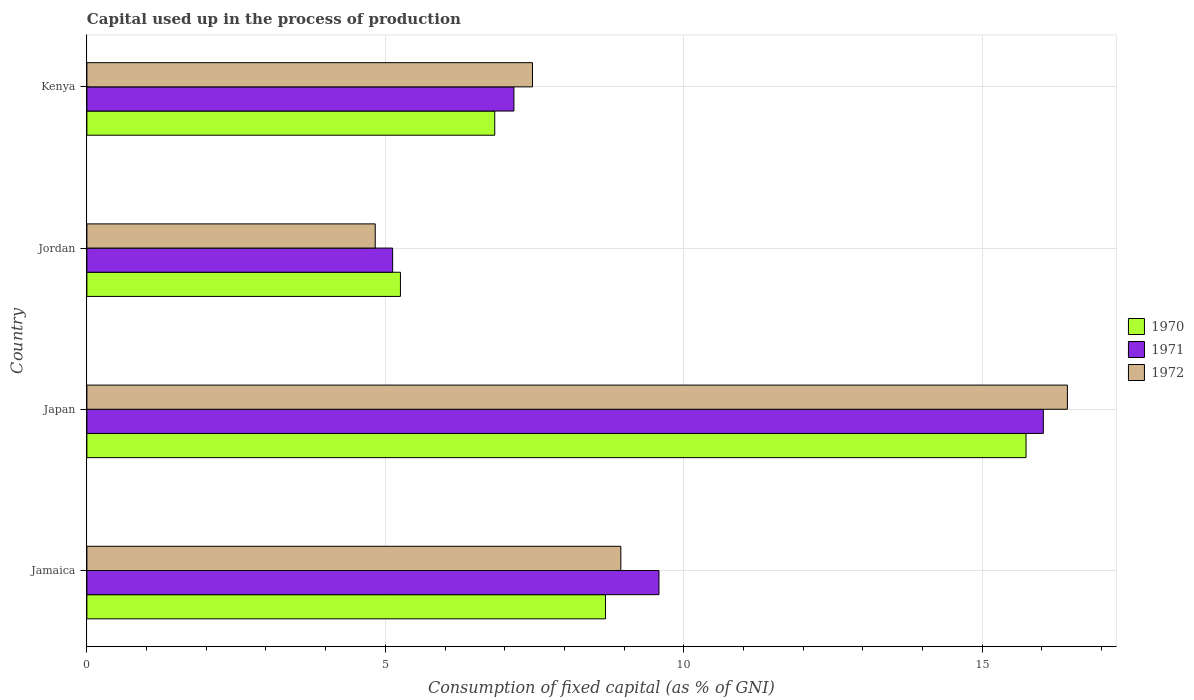Are the number of bars per tick equal to the number of legend labels?
Provide a short and direct response. Yes. Are the number of bars on each tick of the Y-axis equal?
Provide a succinct answer. Yes. How many bars are there on the 4th tick from the bottom?
Your response must be concise. 3. What is the label of the 1st group of bars from the top?
Your answer should be very brief. Kenya. What is the capital used up in the process of production in 1970 in Kenya?
Provide a succinct answer. 6.83. Across all countries, what is the maximum capital used up in the process of production in 1971?
Give a very brief answer. 16.02. Across all countries, what is the minimum capital used up in the process of production in 1971?
Your response must be concise. 5.12. In which country was the capital used up in the process of production in 1972 minimum?
Ensure brevity in your answer.  Jordan. What is the total capital used up in the process of production in 1970 in the graph?
Offer a very short reply. 36.51. What is the difference between the capital used up in the process of production in 1972 in Japan and that in Jordan?
Your answer should be compact. 11.6. What is the difference between the capital used up in the process of production in 1972 in Japan and the capital used up in the process of production in 1970 in Jordan?
Provide a short and direct response. 11.17. What is the average capital used up in the process of production in 1970 per country?
Offer a terse response. 9.13. What is the difference between the capital used up in the process of production in 1971 and capital used up in the process of production in 1970 in Japan?
Give a very brief answer. 0.29. What is the ratio of the capital used up in the process of production in 1972 in Japan to that in Jordan?
Offer a very short reply. 3.4. Is the capital used up in the process of production in 1972 in Japan less than that in Jordan?
Make the answer very short. No. What is the difference between the highest and the second highest capital used up in the process of production in 1972?
Give a very brief answer. 7.48. What is the difference between the highest and the lowest capital used up in the process of production in 1971?
Give a very brief answer. 10.9. Is the sum of the capital used up in the process of production in 1971 in Jamaica and Japan greater than the maximum capital used up in the process of production in 1972 across all countries?
Ensure brevity in your answer.  Yes. What does the 2nd bar from the bottom in Jamaica represents?
Provide a succinct answer. 1971. Is it the case that in every country, the sum of the capital used up in the process of production in 1972 and capital used up in the process of production in 1971 is greater than the capital used up in the process of production in 1970?
Give a very brief answer. Yes. Are all the bars in the graph horizontal?
Make the answer very short. Yes. What is the difference between two consecutive major ticks on the X-axis?
Offer a terse response. 5. Where does the legend appear in the graph?
Your answer should be compact. Center right. How many legend labels are there?
Provide a short and direct response. 3. How are the legend labels stacked?
Your response must be concise. Vertical. What is the title of the graph?
Your answer should be compact. Capital used up in the process of production. Does "2013" appear as one of the legend labels in the graph?
Provide a succinct answer. No. What is the label or title of the X-axis?
Your response must be concise. Consumption of fixed capital (as % of GNI). What is the label or title of the Y-axis?
Your answer should be very brief. Country. What is the Consumption of fixed capital (as % of GNI) in 1970 in Jamaica?
Give a very brief answer. 8.69. What is the Consumption of fixed capital (as % of GNI) in 1971 in Jamaica?
Provide a short and direct response. 9.58. What is the Consumption of fixed capital (as % of GNI) in 1972 in Jamaica?
Offer a very short reply. 8.95. What is the Consumption of fixed capital (as % of GNI) of 1970 in Japan?
Provide a succinct answer. 15.74. What is the Consumption of fixed capital (as % of GNI) of 1971 in Japan?
Your answer should be compact. 16.02. What is the Consumption of fixed capital (as % of GNI) of 1972 in Japan?
Offer a very short reply. 16.43. What is the Consumption of fixed capital (as % of GNI) of 1970 in Jordan?
Give a very brief answer. 5.25. What is the Consumption of fixed capital (as % of GNI) in 1971 in Jordan?
Your response must be concise. 5.12. What is the Consumption of fixed capital (as % of GNI) in 1972 in Jordan?
Your answer should be compact. 4.83. What is the Consumption of fixed capital (as % of GNI) in 1970 in Kenya?
Your answer should be compact. 6.83. What is the Consumption of fixed capital (as % of GNI) of 1971 in Kenya?
Keep it short and to the point. 7.15. What is the Consumption of fixed capital (as % of GNI) of 1972 in Kenya?
Ensure brevity in your answer.  7.47. Across all countries, what is the maximum Consumption of fixed capital (as % of GNI) in 1970?
Offer a terse response. 15.74. Across all countries, what is the maximum Consumption of fixed capital (as % of GNI) in 1971?
Provide a succinct answer. 16.02. Across all countries, what is the maximum Consumption of fixed capital (as % of GNI) of 1972?
Ensure brevity in your answer.  16.43. Across all countries, what is the minimum Consumption of fixed capital (as % of GNI) of 1970?
Your response must be concise. 5.25. Across all countries, what is the minimum Consumption of fixed capital (as % of GNI) of 1971?
Provide a succinct answer. 5.12. Across all countries, what is the minimum Consumption of fixed capital (as % of GNI) of 1972?
Provide a short and direct response. 4.83. What is the total Consumption of fixed capital (as % of GNI) of 1970 in the graph?
Provide a succinct answer. 36.51. What is the total Consumption of fixed capital (as % of GNI) of 1971 in the graph?
Provide a succinct answer. 37.89. What is the total Consumption of fixed capital (as % of GNI) in 1972 in the graph?
Your answer should be very brief. 37.67. What is the difference between the Consumption of fixed capital (as % of GNI) in 1970 in Jamaica and that in Japan?
Offer a very short reply. -7.05. What is the difference between the Consumption of fixed capital (as % of GNI) of 1971 in Jamaica and that in Japan?
Your answer should be very brief. -6.44. What is the difference between the Consumption of fixed capital (as % of GNI) of 1972 in Jamaica and that in Japan?
Your answer should be compact. -7.48. What is the difference between the Consumption of fixed capital (as % of GNI) in 1970 in Jamaica and that in Jordan?
Make the answer very short. 3.44. What is the difference between the Consumption of fixed capital (as % of GNI) in 1971 in Jamaica and that in Jordan?
Provide a succinct answer. 4.46. What is the difference between the Consumption of fixed capital (as % of GNI) of 1972 in Jamaica and that in Jordan?
Provide a short and direct response. 4.11. What is the difference between the Consumption of fixed capital (as % of GNI) of 1970 in Jamaica and that in Kenya?
Provide a succinct answer. 1.86. What is the difference between the Consumption of fixed capital (as % of GNI) in 1971 in Jamaica and that in Kenya?
Offer a very short reply. 2.43. What is the difference between the Consumption of fixed capital (as % of GNI) in 1972 in Jamaica and that in Kenya?
Offer a terse response. 1.48. What is the difference between the Consumption of fixed capital (as % of GNI) of 1970 in Japan and that in Jordan?
Make the answer very short. 10.48. What is the difference between the Consumption of fixed capital (as % of GNI) of 1971 in Japan and that in Jordan?
Your answer should be very brief. 10.9. What is the difference between the Consumption of fixed capital (as % of GNI) in 1972 in Japan and that in Jordan?
Keep it short and to the point. 11.6. What is the difference between the Consumption of fixed capital (as % of GNI) in 1970 in Japan and that in Kenya?
Make the answer very short. 8.9. What is the difference between the Consumption of fixed capital (as % of GNI) in 1971 in Japan and that in Kenya?
Offer a terse response. 8.87. What is the difference between the Consumption of fixed capital (as % of GNI) of 1972 in Japan and that in Kenya?
Offer a very short reply. 8.96. What is the difference between the Consumption of fixed capital (as % of GNI) of 1970 in Jordan and that in Kenya?
Offer a very short reply. -1.58. What is the difference between the Consumption of fixed capital (as % of GNI) of 1971 in Jordan and that in Kenya?
Your answer should be very brief. -2.03. What is the difference between the Consumption of fixed capital (as % of GNI) of 1972 in Jordan and that in Kenya?
Offer a very short reply. -2.63. What is the difference between the Consumption of fixed capital (as % of GNI) in 1970 in Jamaica and the Consumption of fixed capital (as % of GNI) in 1971 in Japan?
Offer a terse response. -7.34. What is the difference between the Consumption of fixed capital (as % of GNI) of 1970 in Jamaica and the Consumption of fixed capital (as % of GNI) of 1972 in Japan?
Your answer should be compact. -7.74. What is the difference between the Consumption of fixed capital (as % of GNI) of 1971 in Jamaica and the Consumption of fixed capital (as % of GNI) of 1972 in Japan?
Provide a short and direct response. -6.84. What is the difference between the Consumption of fixed capital (as % of GNI) of 1970 in Jamaica and the Consumption of fixed capital (as % of GNI) of 1971 in Jordan?
Provide a succinct answer. 3.57. What is the difference between the Consumption of fixed capital (as % of GNI) of 1970 in Jamaica and the Consumption of fixed capital (as % of GNI) of 1972 in Jordan?
Your answer should be compact. 3.86. What is the difference between the Consumption of fixed capital (as % of GNI) in 1971 in Jamaica and the Consumption of fixed capital (as % of GNI) in 1972 in Jordan?
Your response must be concise. 4.75. What is the difference between the Consumption of fixed capital (as % of GNI) of 1970 in Jamaica and the Consumption of fixed capital (as % of GNI) of 1971 in Kenya?
Make the answer very short. 1.53. What is the difference between the Consumption of fixed capital (as % of GNI) of 1970 in Jamaica and the Consumption of fixed capital (as % of GNI) of 1972 in Kenya?
Your answer should be very brief. 1.22. What is the difference between the Consumption of fixed capital (as % of GNI) of 1971 in Jamaica and the Consumption of fixed capital (as % of GNI) of 1972 in Kenya?
Make the answer very short. 2.12. What is the difference between the Consumption of fixed capital (as % of GNI) in 1970 in Japan and the Consumption of fixed capital (as % of GNI) in 1971 in Jordan?
Provide a succinct answer. 10.61. What is the difference between the Consumption of fixed capital (as % of GNI) of 1970 in Japan and the Consumption of fixed capital (as % of GNI) of 1972 in Jordan?
Your answer should be compact. 10.9. What is the difference between the Consumption of fixed capital (as % of GNI) in 1971 in Japan and the Consumption of fixed capital (as % of GNI) in 1972 in Jordan?
Provide a succinct answer. 11.19. What is the difference between the Consumption of fixed capital (as % of GNI) of 1970 in Japan and the Consumption of fixed capital (as % of GNI) of 1971 in Kenya?
Offer a terse response. 8.58. What is the difference between the Consumption of fixed capital (as % of GNI) of 1970 in Japan and the Consumption of fixed capital (as % of GNI) of 1972 in Kenya?
Make the answer very short. 8.27. What is the difference between the Consumption of fixed capital (as % of GNI) in 1971 in Japan and the Consumption of fixed capital (as % of GNI) in 1972 in Kenya?
Ensure brevity in your answer.  8.56. What is the difference between the Consumption of fixed capital (as % of GNI) of 1970 in Jordan and the Consumption of fixed capital (as % of GNI) of 1971 in Kenya?
Provide a short and direct response. -1.9. What is the difference between the Consumption of fixed capital (as % of GNI) in 1970 in Jordan and the Consumption of fixed capital (as % of GNI) in 1972 in Kenya?
Offer a very short reply. -2.21. What is the difference between the Consumption of fixed capital (as % of GNI) in 1971 in Jordan and the Consumption of fixed capital (as % of GNI) in 1972 in Kenya?
Offer a terse response. -2.34. What is the average Consumption of fixed capital (as % of GNI) in 1970 per country?
Make the answer very short. 9.13. What is the average Consumption of fixed capital (as % of GNI) of 1971 per country?
Give a very brief answer. 9.47. What is the average Consumption of fixed capital (as % of GNI) of 1972 per country?
Provide a short and direct response. 9.42. What is the difference between the Consumption of fixed capital (as % of GNI) of 1970 and Consumption of fixed capital (as % of GNI) of 1971 in Jamaica?
Ensure brevity in your answer.  -0.9. What is the difference between the Consumption of fixed capital (as % of GNI) in 1970 and Consumption of fixed capital (as % of GNI) in 1972 in Jamaica?
Give a very brief answer. -0.26. What is the difference between the Consumption of fixed capital (as % of GNI) of 1971 and Consumption of fixed capital (as % of GNI) of 1972 in Jamaica?
Make the answer very short. 0.64. What is the difference between the Consumption of fixed capital (as % of GNI) in 1970 and Consumption of fixed capital (as % of GNI) in 1971 in Japan?
Provide a short and direct response. -0.29. What is the difference between the Consumption of fixed capital (as % of GNI) in 1970 and Consumption of fixed capital (as % of GNI) in 1972 in Japan?
Keep it short and to the point. -0.69. What is the difference between the Consumption of fixed capital (as % of GNI) in 1971 and Consumption of fixed capital (as % of GNI) in 1972 in Japan?
Keep it short and to the point. -0.4. What is the difference between the Consumption of fixed capital (as % of GNI) in 1970 and Consumption of fixed capital (as % of GNI) in 1971 in Jordan?
Make the answer very short. 0.13. What is the difference between the Consumption of fixed capital (as % of GNI) in 1970 and Consumption of fixed capital (as % of GNI) in 1972 in Jordan?
Keep it short and to the point. 0.42. What is the difference between the Consumption of fixed capital (as % of GNI) of 1971 and Consumption of fixed capital (as % of GNI) of 1972 in Jordan?
Make the answer very short. 0.29. What is the difference between the Consumption of fixed capital (as % of GNI) in 1970 and Consumption of fixed capital (as % of GNI) in 1971 in Kenya?
Offer a very short reply. -0.32. What is the difference between the Consumption of fixed capital (as % of GNI) of 1970 and Consumption of fixed capital (as % of GNI) of 1972 in Kenya?
Your answer should be very brief. -0.63. What is the difference between the Consumption of fixed capital (as % of GNI) of 1971 and Consumption of fixed capital (as % of GNI) of 1972 in Kenya?
Ensure brevity in your answer.  -0.31. What is the ratio of the Consumption of fixed capital (as % of GNI) of 1970 in Jamaica to that in Japan?
Your answer should be very brief. 0.55. What is the ratio of the Consumption of fixed capital (as % of GNI) of 1971 in Jamaica to that in Japan?
Give a very brief answer. 0.6. What is the ratio of the Consumption of fixed capital (as % of GNI) in 1972 in Jamaica to that in Japan?
Your response must be concise. 0.54. What is the ratio of the Consumption of fixed capital (as % of GNI) of 1970 in Jamaica to that in Jordan?
Offer a terse response. 1.65. What is the ratio of the Consumption of fixed capital (as % of GNI) in 1971 in Jamaica to that in Jordan?
Offer a very short reply. 1.87. What is the ratio of the Consumption of fixed capital (as % of GNI) in 1972 in Jamaica to that in Jordan?
Offer a terse response. 1.85. What is the ratio of the Consumption of fixed capital (as % of GNI) of 1970 in Jamaica to that in Kenya?
Provide a succinct answer. 1.27. What is the ratio of the Consumption of fixed capital (as % of GNI) in 1971 in Jamaica to that in Kenya?
Your response must be concise. 1.34. What is the ratio of the Consumption of fixed capital (as % of GNI) in 1972 in Jamaica to that in Kenya?
Give a very brief answer. 1.2. What is the ratio of the Consumption of fixed capital (as % of GNI) of 1970 in Japan to that in Jordan?
Provide a succinct answer. 3. What is the ratio of the Consumption of fixed capital (as % of GNI) of 1971 in Japan to that in Jordan?
Offer a very short reply. 3.13. What is the ratio of the Consumption of fixed capital (as % of GNI) in 1972 in Japan to that in Jordan?
Your response must be concise. 3.4. What is the ratio of the Consumption of fixed capital (as % of GNI) of 1970 in Japan to that in Kenya?
Offer a very short reply. 2.3. What is the ratio of the Consumption of fixed capital (as % of GNI) in 1971 in Japan to that in Kenya?
Your response must be concise. 2.24. What is the ratio of the Consumption of fixed capital (as % of GNI) in 1972 in Japan to that in Kenya?
Provide a short and direct response. 2.2. What is the ratio of the Consumption of fixed capital (as % of GNI) in 1970 in Jordan to that in Kenya?
Your answer should be very brief. 0.77. What is the ratio of the Consumption of fixed capital (as % of GNI) in 1971 in Jordan to that in Kenya?
Provide a succinct answer. 0.72. What is the ratio of the Consumption of fixed capital (as % of GNI) in 1972 in Jordan to that in Kenya?
Ensure brevity in your answer.  0.65. What is the difference between the highest and the second highest Consumption of fixed capital (as % of GNI) of 1970?
Give a very brief answer. 7.05. What is the difference between the highest and the second highest Consumption of fixed capital (as % of GNI) of 1971?
Your answer should be compact. 6.44. What is the difference between the highest and the second highest Consumption of fixed capital (as % of GNI) in 1972?
Keep it short and to the point. 7.48. What is the difference between the highest and the lowest Consumption of fixed capital (as % of GNI) of 1970?
Your answer should be very brief. 10.48. What is the difference between the highest and the lowest Consumption of fixed capital (as % of GNI) in 1971?
Your answer should be very brief. 10.9. What is the difference between the highest and the lowest Consumption of fixed capital (as % of GNI) of 1972?
Your answer should be compact. 11.6. 